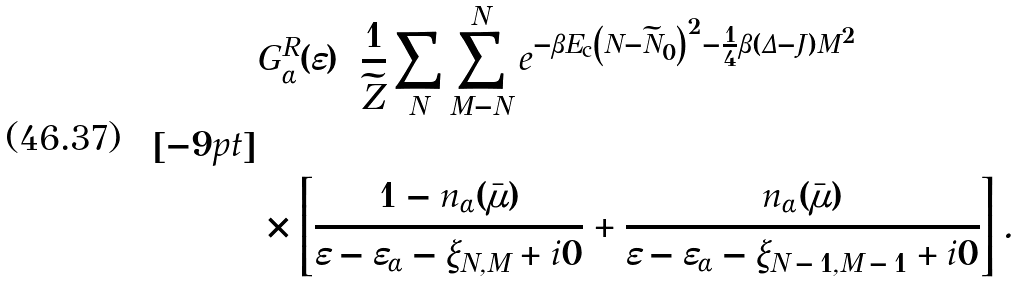<formula> <loc_0><loc_0><loc_500><loc_500>& { G } _ { \alpha } ^ { R } ( \varepsilon ) = \frac { 1 } { \widetilde { Z } } \sum _ { N } \sum _ { M = - N } ^ { N } e ^ { - \beta E _ { \text {c} } \left ( N - \widetilde { N } _ { 0 } \right ) ^ { 2 } - \frac { 1 } { 4 } \beta ( \Delta - J ) M ^ { 2 } } \\ [ - 9 p t ] \\ & \times \left [ \frac { 1 - n _ { \alpha } ( \bar { \mu } ) } { \varepsilon - \varepsilon _ { \alpha } - \xi _ { N , M } + { i } 0 } + \frac { n _ { \alpha } ( \bar { \mu } ) } { \varepsilon - \varepsilon _ { \alpha } - \xi _ { N \, - \, 1 , M \, - \, 1 } + { i } 0 } \right ] .</formula> 